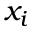Convert formula to latex. <formula><loc_0><loc_0><loc_500><loc_500>x _ { i }</formula> 